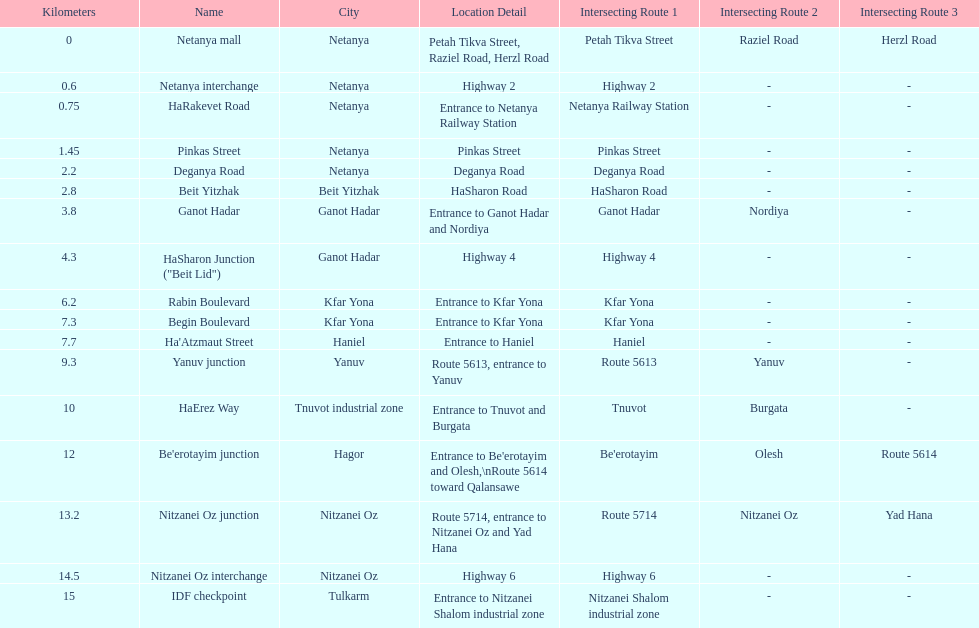After you complete deganya road, what portion comes next? Beit Yitzhak. 